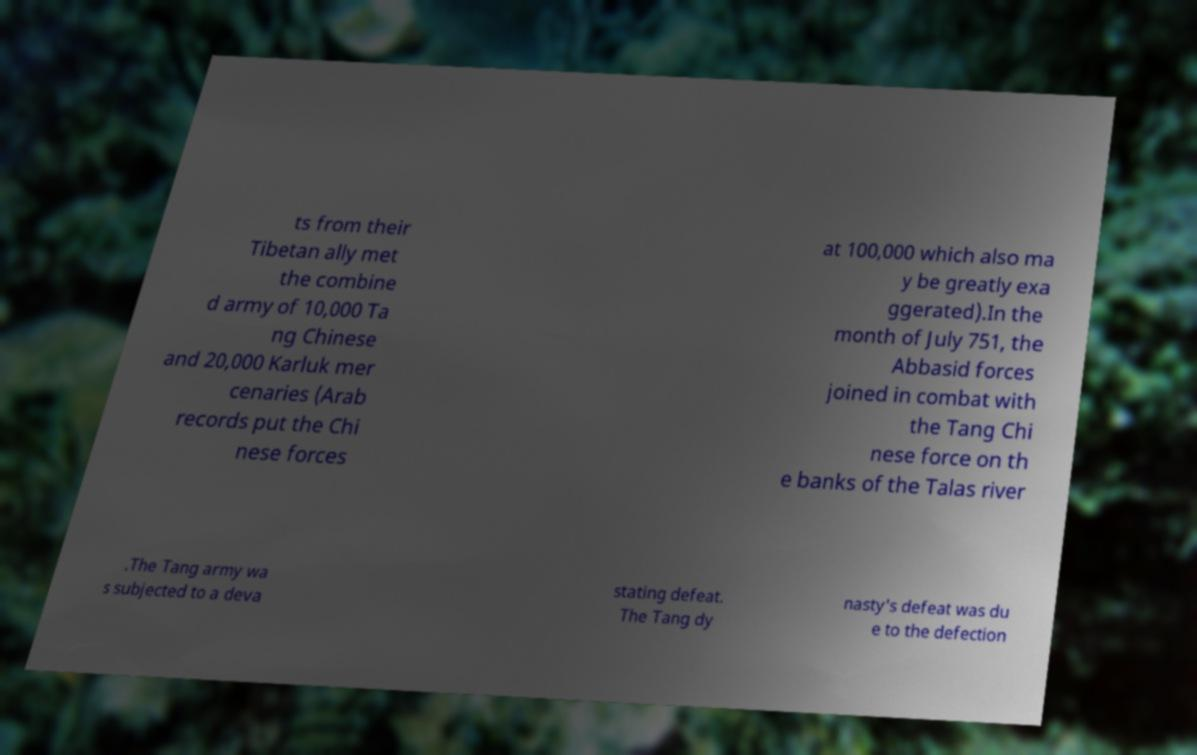There's text embedded in this image that I need extracted. Can you transcribe it verbatim? ts from their Tibetan ally met the combine d army of 10,000 Ta ng Chinese and 20,000 Karluk mer cenaries (Arab records put the Chi nese forces at 100,000 which also ma y be greatly exa ggerated).In the month of July 751, the Abbasid forces joined in combat with the Tang Chi nese force on th e banks of the Talas river .The Tang army wa s subjected to a deva stating defeat. The Tang dy nasty's defeat was du e to the defection 